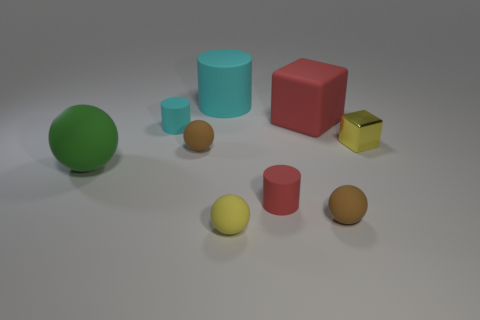Is there anything else that has the same material as the yellow cube?
Your answer should be very brief. No. What is the material of the tiny yellow thing left of the yellow thing that is behind the small yellow rubber sphere?
Make the answer very short. Rubber. Is there another large cyan rubber object that has the same shape as the big cyan rubber object?
Provide a short and direct response. No. What color is the block that is the same size as the green ball?
Provide a short and direct response. Red. How many objects are either tiny brown rubber things that are on the left side of the matte block or green objects to the left of the yellow ball?
Your answer should be compact. 2. How many objects are either big green things or balls?
Your answer should be compact. 4. How big is the rubber thing that is behind the tiny cyan matte thing and left of the large rubber block?
Provide a succinct answer. Large. How many large green objects have the same material as the yellow block?
Provide a short and direct response. 0. What is the color of the cube that is made of the same material as the red cylinder?
Ensure brevity in your answer.  Red. Does the tiny rubber cylinder behind the small red cylinder have the same color as the big cylinder?
Offer a very short reply. Yes. 